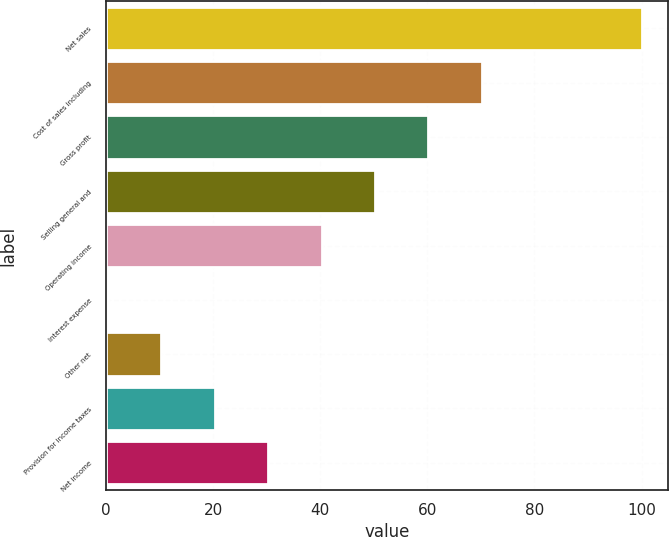Convert chart to OTSL. <chart><loc_0><loc_0><loc_500><loc_500><bar_chart><fcel>Net sales<fcel>Cost of sales including<fcel>Gross profit<fcel>Selling general and<fcel>Operating income<fcel>Interest expense<fcel>Other net<fcel>Provision for income taxes<fcel>Net income<nl><fcel>100<fcel>70.12<fcel>60.16<fcel>50.2<fcel>40.24<fcel>0.4<fcel>10.36<fcel>20.32<fcel>30.28<nl></chart> 